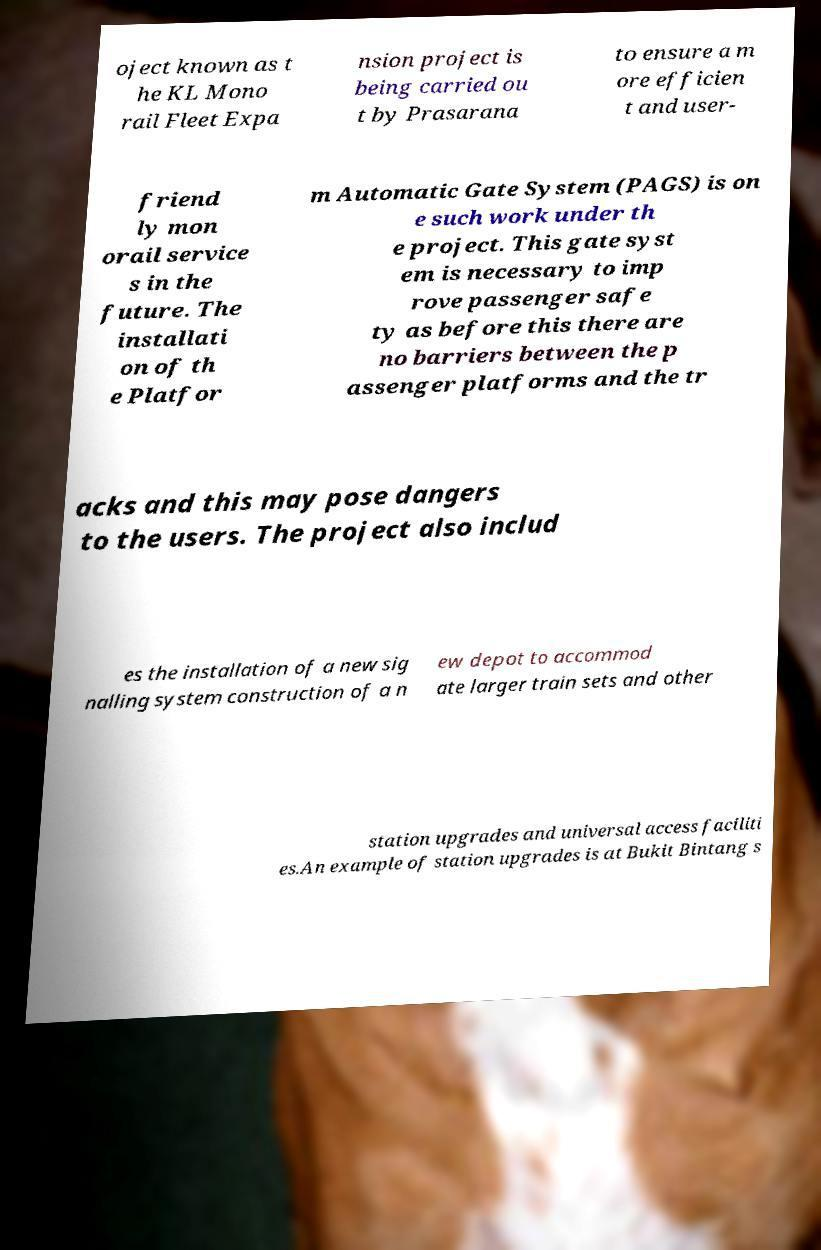Please identify and transcribe the text found in this image. oject known as t he KL Mono rail Fleet Expa nsion project is being carried ou t by Prasarana to ensure a m ore efficien t and user- friend ly mon orail service s in the future. The installati on of th e Platfor m Automatic Gate System (PAGS) is on e such work under th e project. This gate syst em is necessary to imp rove passenger safe ty as before this there are no barriers between the p assenger platforms and the tr acks and this may pose dangers to the users. The project also includ es the installation of a new sig nalling system construction of a n ew depot to accommod ate larger train sets and other station upgrades and universal access faciliti es.An example of station upgrades is at Bukit Bintang s 